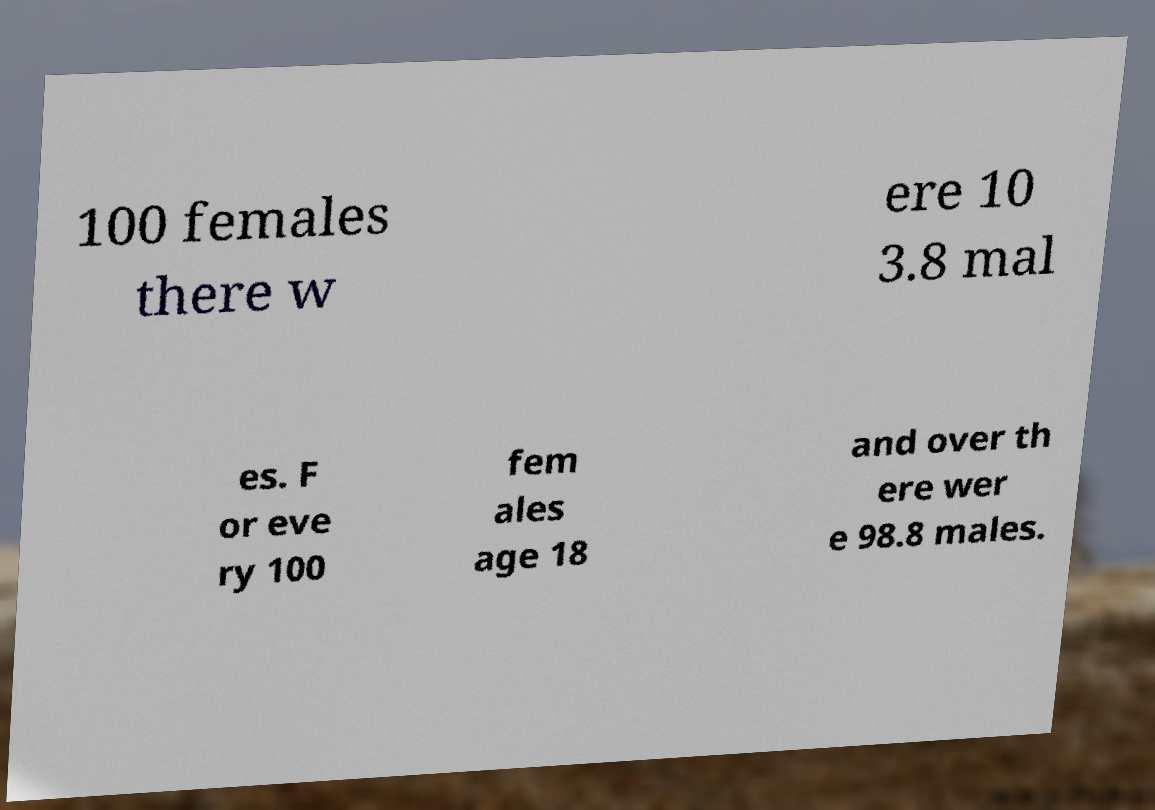There's text embedded in this image that I need extracted. Can you transcribe it verbatim? 100 females there w ere 10 3.8 mal es. F or eve ry 100 fem ales age 18 and over th ere wer e 98.8 males. 